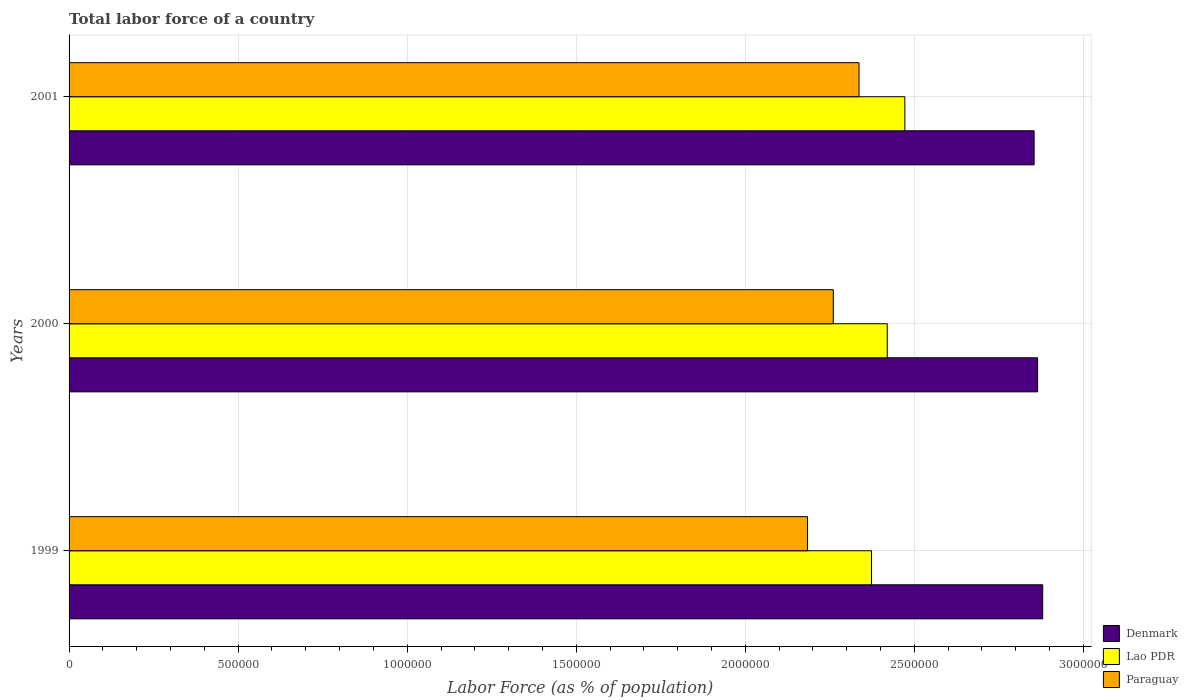Are the number of bars per tick equal to the number of legend labels?
Offer a terse response. Yes. How many bars are there on the 2nd tick from the bottom?
Offer a terse response. 3. In how many cases, is the number of bars for a given year not equal to the number of legend labels?
Provide a succinct answer. 0. What is the percentage of labor force in Denmark in 2001?
Make the answer very short. 2.85e+06. Across all years, what is the maximum percentage of labor force in Lao PDR?
Your answer should be very brief. 2.47e+06. Across all years, what is the minimum percentage of labor force in Denmark?
Provide a succinct answer. 2.85e+06. In which year was the percentage of labor force in Lao PDR maximum?
Ensure brevity in your answer.  2001. What is the total percentage of labor force in Lao PDR in the graph?
Make the answer very short. 7.26e+06. What is the difference between the percentage of labor force in Lao PDR in 1999 and that in 2001?
Offer a very short reply. -9.86e+04. What is the difference between the percentage of labor force in Paraguay in 1999 and the percentage of labor force in Lao PDR in 2001?
Offer a very short reply. -2.88e+05. What is the average percentage of labor force in Lao PDR per year?
Provide a short and direct response. 2.42e+06. In the year 2001, what is the difference between the percentage of labor force in Lao PDR and percentage of labor force in Paraguay?
Ensure brevity in your answer.  1.36e+05. In how many years, is the percentage of labor force in Denmark greater than 1000000 %?
Ensure brevity in your answer.  3. What is the ratio of the percentage of labor force in Denmark in 1999 to that in 2000?
Keep it short and to the point. 1.01. Is the percentage of labor force in Lao PDR in 1999 less than that in 2000?
Give a very brief answer. Yes. What is the difference between the highest and the second highest percentage of labor force in Paraguay?
Your response must be concise. 7.61e+04. What is the difference between the highest and the lowest percentage of labor force in Paraguay?
Provide a short and direct response. 1.52e+05. In how many years, is the percentage of labor force in Paraguay greater than the average percentage of labor force in Paraguay taken over all years?
Provide a succinct answer. 2. What does the 3rd bar from the bottom in 2001 represents?
Make the answer very short. Paraguay. Is it the case that in every year, the sum of the percentage of labor force in Denmark and percentage of labor force in Paraguay is greater than the percentage of labor force in Lao PDR?
Your answer should be very brief. Yes. Are all the bars in the graph horizontal?
Provide a succinct answer. Yes. How many years are there in the graph?
Your answer should be very brief. 3. What is the difference between two consecutive major ticks on the X-axis?
Make the answer very short. 5.00e+05. Are the values on the major ticks of X-axis written in scientific E-notation?
Ensure brevity in your answer.  No. Does the graph contain grids?
Give a very brief answer. Yes. Where does the legend appear in the graph?
Your response must be concise. Bottom right. What is the title of the graph?
Offer a terse response. Total labor force of a country. Does "Middle East & North Africa (developing only)" appear as one of the legend labels in the graph?
Your response must be concise. No. What is the label or title of the X-axis?
Your answer should be compact. Labor Force (as % of population). What is the Labor Force (as % of population) of Denmark in 1999?
Offer a terse response. 2.88e+06. What is the Labor Force (as % of population) of Lao PDR in 1999?
Provide a short and direct response. 2.37e+06. What is the Labor Force (as % of population) in Paraguay in 1999?
Your answer should be compact. 2.18e+06. What is the Labor Force (as % of population) of Denmark in 2000?
Your answer should be very brief. 2.86e+06. What is the Labor Force (as % of population) of Lao PDR in 2000?
Provide a short and direct response. 2.42e+06. What is the Labor Force (as % of population) in Paraguay in 2000?
Provide a short and direct response. 2.26e+06. What is the Labor Force (as % of population) in Denmark in 2001?
Provide a short and direct response. 2.85e+06. What is the Labor Force (as % of population) of Lao PDR in 2001?
Provide a short and direct response. 2.47e+06. What is the Labor Force (as % of population) of Paraguay in 2001?
Provide a short and direct response. 2.34e+06. Across all years, what is the maximum Labor Force (as % of population) of Denmark?
Offer a terse response. 2.88e+06. Across all years, what is the maximum Labor Force (as % of population) of Lao PDR?
Make the answer very short. 2.47e+06. Across all years, what is the maximum Labor Force (as % of population) in Paraguay?
Keep it short and to the point. 2.34e+06. Across all years, what is the minimum Labor Force (as % of population) of Denmark?
Your answer should be very brief. 2.85e+06. Across all years, what is the minimum Labor Force (as % of population) of Lao PDR?
Your answer should be compact. 2.37e+06. Across all years, what is the minimum Labor Force (as % of population) in Paraguay?
Provide a succinct answer. 2.18e+06. What is the total Labor Force (as % of population) in Denmark in the graph?
Your response must be concise. 8.60e+06. What is the total Labor Force (as % of population) of Lao PDR in the graph?
Offer a very short reply. 7.26e+06. What is the total Labor Force (as % of population) in Paraguay in the graph?
Offer a terse response. 6.78e+06. What is the difference between the Labor Force (as % of population) of Denmark in 1999 and that in 2000?
Keep it short and to the point. 1.50e+04. What is the difference between the Labor Force (as % of population) in Lao PDR in 1999 and that in 2000?
Ensure brevity in your answer.  -4.66e+04. What is the difference between the Labor Force (as % of population) in Paraguay in 1999 and that in 2000?
Your response must be concise. -7.62e+04. What is the difference between the Labor Force (as % of population) of Denmark in 1999 and that in 2001?
Provide a succinct answer. 2.53e+04. What is the difference between the Labor Force (as % of population) in Lao PDR in 1999 and that in 2001?
Make the answer very short. -9.86e+04. What is the difference between the Labor Force (as % of population) of Paraguay in 1999 and that in 2001?
Offer a terse response. -1.52e+05. What is the difference between the Labor Force (as % of population) of Denmark in 2000 and that in 2001?
Provide a short and direct response. 1.04e+04. What is the difference between the Labor Force (as % of population) in Lao PDR in 2000 and that in 2001?
Give a very brief answer. -5.21e+04. What is the difference between the Labor Force (as % of population) in Paraguay in 2000 and that in 2001?
Your answer should be compact. -7.61e+04. What is the difference between the Labor Force (as % of population) of Denmark in 1999 and the Labor Force (as % of population) of Lao PDR in 2000?
Provide a short and direct response. 4.60e+05. What is the difference between the Labor Force (as % of population) of Denmark in 1999 and the Labor Force (as % of population) of Paraguay in 2000?
Ensure brevity in your answer.  6.19e+05. What is the difference between the Labor Force (as % of population) of Lao PDR in 1999 and the Labor Force (as % of population) of Paraguay in 2000?
Give a very brief answer. 1.13e+05. What is the difference between the Labor Force (as % of population) of Denmark in 1999 and the Labor Force (as % of population) of Lao PDR in 2001?
Make the answer very short. 4.08e+05. What is the difference between the Labor Force (as % of population) in Denmark in 1999 and the Labor Force (as % of population) in Paraguay in 2001?
Provide a short and direct response. 5.43e+05. What is the difference between the Labor Force (as % of population) of Lao PDR in 1999 and the Labor Force (as % of population) of Paraguay in 2001?
Make the answer very short. 3.69e+04. What is the difference between the Labor Force (as % of population) in Denmark in 2000 and the Labor Force (as % of population) in Lao PDR in 2001?
Your answer should be compact. 3.93e+05. What is the difference between the Labor Force (as % of population) of Denmark in 2000 and the Labor Force (as % of population) of Paraguay in 2001?
Your response must be concise. 5.28e+05. What is the difference between the Labor Force (as % of population) in Lao PDR in 2000 and the Labor Force (as % of population) in Paraguay in 2001?
Provide a short and direct response. 8.35e+04. What is the average Labor Force (as % of population) of Denmark per year?
Your answer should be very brief. 2.87e+06. What is the average Labor Force (as % of population) of Lao PDR per year?
Give a very brief answer. 2.42e+06. What is the average Labor Force (as % of population) in Paraguay per year?
Provide a succinct answer. 2.26e+06. In the year 1999, what is the difference between the Labor Force (as % of population) of Denmark and Labor Force (as % of population) of Lao PDR?
Provide a succinct answer. 5.06e+05. In the year 1999, what is the difference between the Labor Force (as % of population) of Denmark and Labor Force (as % of population) of Paraguay?
Your response must be concise. 6.96e+05. In the year 1999, what is the difference between the Labor Force (as % of population) in Lao PDR and Labor Force (as % of population) in Paraguay?
Your response must be concise. 1.89e+05. In the year 2000, what is the difference between the Labor Force (as % of population) of Denmark and Labor Force (as % of population) of Lao PDR?
Your answer should be compact. 4.45e+05. In the year 2000, what is the difference between the Labor Force (as % of population) in Denmark and Labor Force (as % of population) in Paraguay?
Keep it short and to the point. 6.04e+05. In the year 2000, what is the difference between the Labor Force (as % of population) in Lao PDR and Labor Force (as % of population) in Paraguay?
Ensure brevity in your answer.  1.60e+05. In the year 2001, what is the difference between the Labor Force (as % of population) in Denmark and Labor Force (as % of population) in Lao PDR?
Provide a succinct answer. 3.82e+05. In the year 2001, what is the difference between the Labor Force (as % of population) in Denmark and Labor Force (as % of population) in Paraguay?
Ensure brevity in your answer.  5.18e+05. In the year 2001, what is the difference between the Labor Force (as % of population) of Lao PDR and Labor Force (as % of population) of Paraguay?
Offer a terse response. 1.36e+05. What is the ratio of the Labor Force (as % of population) of Lao PDR in 1999 to that in 2000?
Your answer should be very brief. 0.98. What is the ratio of the Labor Force (as % of population) of Paraguay in 1999 to that in 2000?
Give a very brief answer. 0.97. What is the ratio of the Labor Force (as % of population) of Denmark in 1999 to that in 2001?
Offer a very short reply. 1.01. What is the ratio of the Labor Force (as % of population) of Lao PDR in 1999 to that in 2001?
Give a very brief answer. 0.96. What is the ratio of the Labor Force (as % of population) in Paraguay in 1999 to that in 2001?
Provide a short and direct response. 0.93. What is the ratio of the Labor Force (as % of population) of Denmark in 2000 to that in 2001?
Give a very brief answer. 1. What is the ratio of the Labor Force (as % of population) in Lao PDR in 2000 to that in 2001?
Make the answer very short. 0.98. What is the ratio of the Labor Force (as % of population) in Paraguay in 2000 to that in 2001?
Give a very brief answer. 0.97. What is the difference between the highest and the second highest Labor Force (as % of population) of Denmark?
Give a very brief answer. 1.50e+04. What is the difference between the highest and the second highest Labor Force (as % of population) in Lao PDR?
Make the answer very short. 5.21e+04. What is the difference between the highest and the second highest Labor Force (as % of population) of Paraguay?
Ensure brevity in your answer.  7.61e+04. What is the difference between the highest and the lowest Labor Force (as % of population) in Denmark?
Give a very brief answer. 2.53e+04. What is the difference between the highest and the lowest Labor Force (as % of population) of Lao PDR?
Keep it short and to the point. 9.86e+04. What is the difference between the highest and the lowest Labor Force (as % of population) of Paraguay?
Provide a short and direct response. 1.52e+05. 